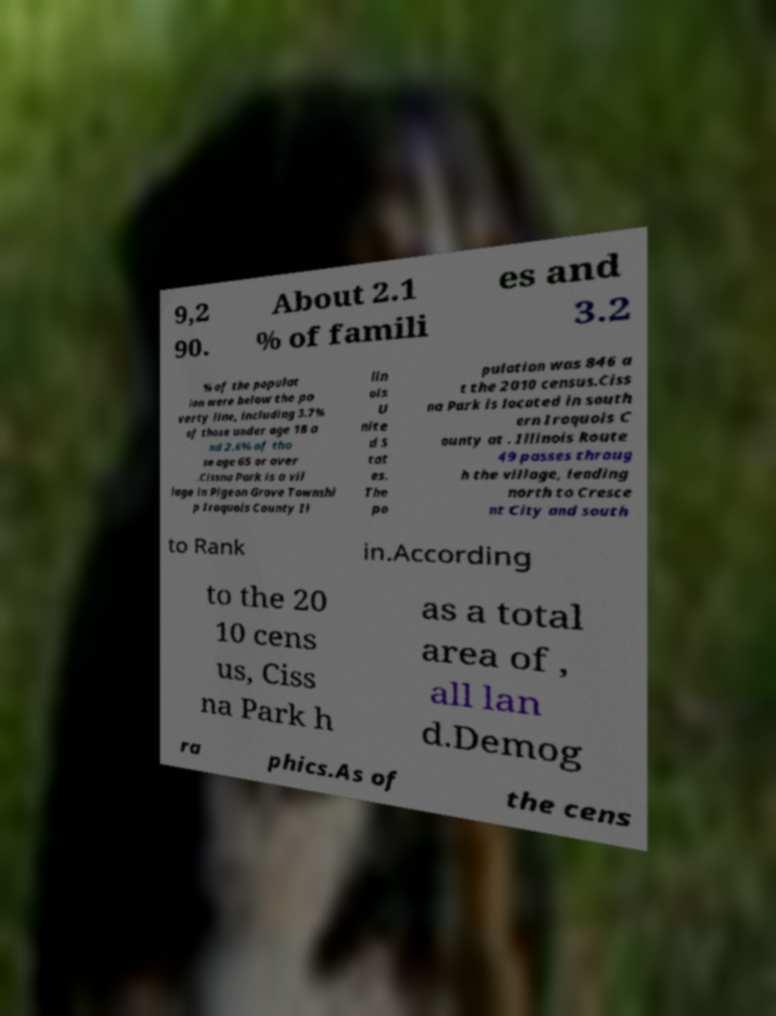What messages or text are displayed in this image? I need them in a readable, typed format. 9,2 90. About 2.1 % of famili es and 3.2 % of the populat ion were below the po verty line, including 3.7% of those under age 18 a nd 2.6% of tho se age 65 or over .Cissna Park is a vil lage in Pigeon Grove Townshi p Iroquois County Il lin ois U nite d S tat es. The po pulation was 846 a t the 2010 census.Ciss na Park is located in south ern Iroquois C ounty at . Illinois Route 49 passes throug h the village, leading north to Cresce nt City and south to Rank in.According to the 20 10 cens us, Ciss na Park h as a total area of , all lan d.Demog ra phics.As of the cens 